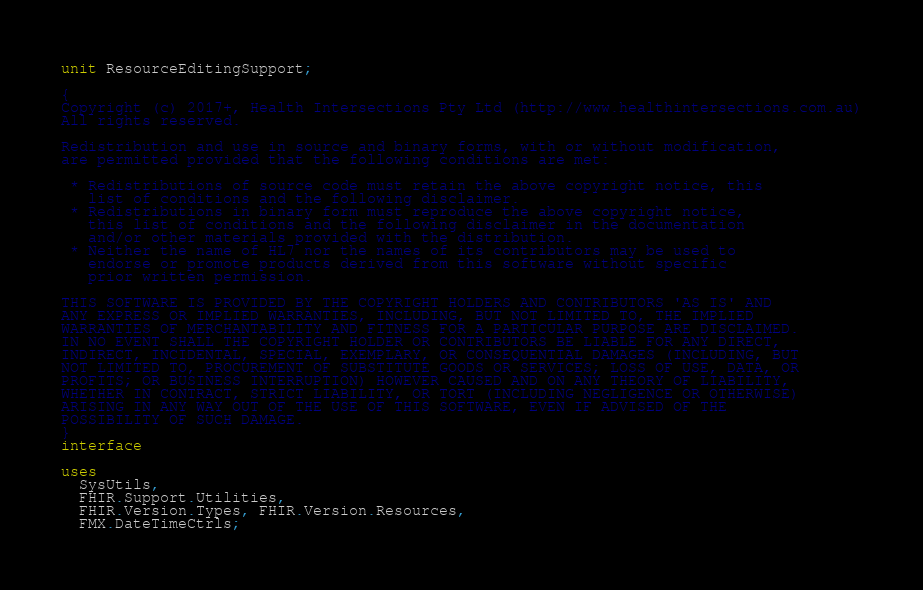Convert code to text. <code><loc_0><loc_0><loc_500><loc_500><_Pascal_>unit ResourceEditingSupport;

{
Copyright (c) 2017+, Health Intersections Pty Ltd (http://www.healthintersections.com.au)
All rights reserved.

Redistribution and use in source and binary forms, with or without modification,
are permitted provided that the following conditions are met:

 * Redistributions of source code must retain the above copyright notice, this
   list of conditions and the following disclaimer.
 * Redistributions in binary form must reproduce the above copyright notice,
   this list of conditions and the following disclaimer in the documentation
   and/or other materials provided with the distribution.
 * Neither the name of HL7 nor the names of its contributors may be used to
   endorse or promote products derived from this software without specific
   prior written permission.

THIS SOFTWARE IS PROVIDED BY THE COPYRIGHT HOLDERS AND CONTRIBUTORS 'AS IS' AND
ANY EXPRESS OR IMPLIED WARRANTIES, INCLUDING, BUT NOT LIMITED TO, THE IMPLIED
WARRANTIES OF MERCHANTABILITY AND FITNESS FOR A PARTICULAR PURPOSE ARE DISCLAIMED.
IN NO EVENT SHALL THE COPYRIGHT HOLDER OR CONTRIBUTORS BE LIABLE FOR ANY DIRECT,
INDIRECT, INCIDENTAL, SPECIAL, EXEMPLARY, OR CONSEQUENTIAL DAMAGES (INCLUDING, BUT
NOT LIMITED TO, PROCUREMENT OF SUBSTITUTE GOODS OR SERVICES; LOSS OF USE, DATA, OR
PROFITS; OR BUSINESS INTERRUPTION) HOWEVER CAUSED AND ON ANY THEORY OF LIABILITY,
WHETHER IN CONTRACT, STRICT LIABILITY, OR TORT (INCLUDING NEGLIGENCE OR OTHERWISE)
ARISING IN ANY WAY OUT OF THE USE OF THIS SOFTWARE, EVEN IF ADVISED OF THE
POSSIBILITY OF SUCH DAMAGE.
}
interface

uses
  SysUtils,
  FHIR.Support.Utilities,
  FHIR.Version.Types, FHIR.Version.Resources,
  FMX.DateTimeCtrls;
</code> 